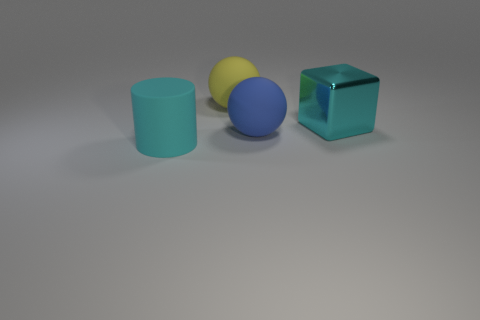Add 2 tiny red matte blocks. How many objects exist? 6 Subtract all blocks. How many objects are left? 3 Subtract all big yellow matte objects. Subtract all big balls. How many objects are left? 1 Add 3 big cyan metallic cubes. How many big cyan metallic cubes are left? 4 Add 4 large gray spheres. How many large gray spheres exist? 4 Subtract 0 green cubes. How many objects are left? 4 